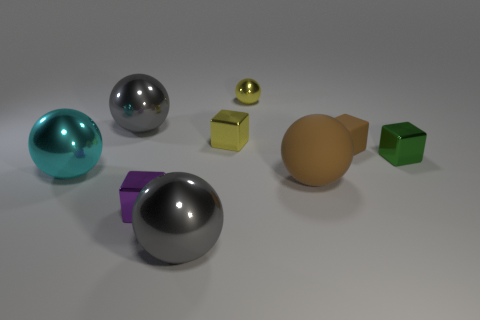How many things are rubber objects or large balls left of the big rubber sphere?
Ensure brevity in your answer.  5. There is a yellow cube that is the same material as the cyan ball; what is its size?
Offer a terse response. Small. Are there more purple metal things left of the tiny brown rubber block than purple metallic blocks?
Your response must be concise. No. What is the size of the object that is behind the big brown ball and in front of the tiny green shiny object?
Make the answer very short. Large. What material is the other small object that is the same shape as the cyan shiny thing?
Provide a short and direct response. Metal. There is a thing that is in front of the purple metal cube; is its size the same as the green shiny cube?
Give a very brief answer. No. There is a tiny cube that is left of the small brown rubber thing and in front of the small brown matte object; what is its color?
Offer a terse response. Purple. What number of small shiny objects are on the right side of the tiny yellow object behind the small yellow cube?
Your response must be concise. 1. Does the cyan thing have the same shape as the purple metal object?
Ensure brevity in your answer.  No. Is there anything else that is the same color as the small metallic sphere?
Offer a terse response. Yes. 